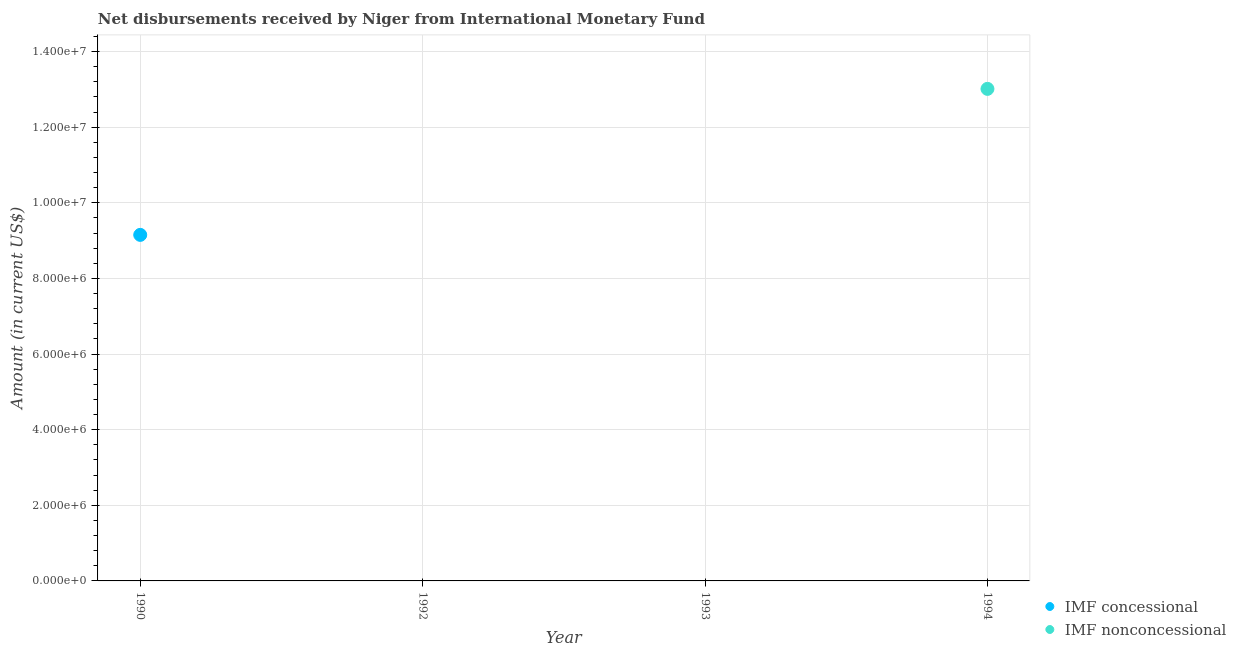What is the net concessional disbursements from imf in 1992?
Your response must be concise. 0. Across all years, what is the maximum net non concessional disbursements from imf?
Make the answer very short. 1.30e+07. What is the total net non concessional disbursements from imf in the graph?
Your response must be concise. 1.30e+07. What is the difference between the net non concessional disbursements from imf in 1993 and the net concessional disbursements from imf in 1990?
Your response must be concise. -9.15e+06. What is the average net non concessional disbursements from imf per year?
Make the answer very short. 3.25e+06. In how many years, is the net concessional disbursements from imf greater than 11600000 US$?
Your response must be concise. 0. What is the difference between the highest and the lowest net non concessional disbursements from imf?
Offer a very short reply. 1.30e+07. In how many years, is the net non concessional disbursements from imf greater than the average net non concessional disbursements from imf taken over all years?
Ensure brevity in your answer.  1. Does the net non concessional disbursements from imf monotonically increase over the years?
Keep it short and to the point. Yes. How many dotlines are there?
Your response must be concise. 2. What is the difference between two consecutive major ticks on the Y-axis?
Your response must be concise. 2.00e+06. Where does the legend appear in the graph?
Give a very brief answer. Bottom right. What is the title of the graph?
Offer a terse response. Net disbursements received by Niger from International Monetary Fund. What is the label or title of the X-axis?
Make the answer very short. Year. What is the label or title of the Y-axis?
Your response must be concise. Amount (in current US$). What is the Amount (in current US$) in IMF concessional in 1990?
Make the answer very short. 9.15e+06. What is the Amount (in current US$) of IMF nonconcessional in 1990?
Your answer should be compact. 0. What is the Amount (in current US$) of IMF concessional in 1992?
Give a very brief answer. 0. What is the Amount (in current US$) in IMF concessional in 1993?
Provide a short and direct response. 0. What is the Amount (in current US$) of IMF nonconcessional in 1993?
Your answer should be very brief. 0. What is the Amount (in current US$) in IMF concessional in 1994?
Give a very brief answer. 0. What is the Amount (in current US$) in IMF nonconcessional in 1994?
Make the answer very short. 1.30e+07. Across all years, what is the maximum Amount (in current US$) of IMF concessional?
Your answer should be compact. 9.15e+06. Across all years, what is the maximum Amount (in current US$) in IMF nonconcessional?
Provide a short and direct response. 1.30e+07. Across all years, what is the minimum Amount (in current US$) of IMF concessional?
Provide a succinct answer. 0. Across all years, what is the minimum Amount (in current US$) in IMF nonconcessional?
Your response must be concise. 0. What is the total Amount (in current US$) of IMF concessional in the graph?
Offer a very short reply. 9.15e+06. What is the total Amount (in current US$) in IMF nonconcessional in the graph?
Give a very brief answer. 1.30e+07. What is the difference between the Amount (in current US$) of IMF concessional in 1990 and the Amount (in current US$) of IMF nonconcessional in 1994?
Keep it short and to the point. -3.86e+06. What is the average Amount (in current US$) of IMF concessional per year?
Provide a succinct answer. 2.29e+06. What is the average Amount (in current US$) in IMF nonconcessional per year?
Offer a very short reply. 3.25e+06. What is the difference between the highest and the lowest Amount (in current US$) of IMF concessional?
Keep it short and to the point. 9.15e+06. What is the difference between the highest and the lowest Amount (in current US$) of IMF nonconcessional?
Provide a succinct answer. 1.30e+07. 